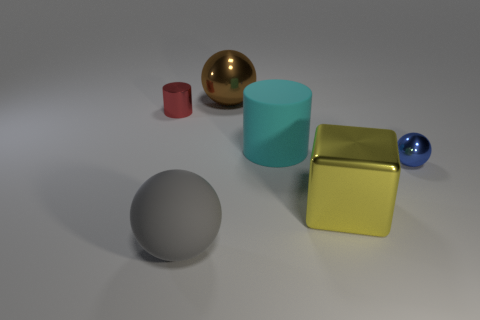What is the shape of the big cyan object?
Your answer should be compact. Cylinder. What is the size of the metal sphere that is behind the red metallic cylinder that is in front of the large metal thing behind the tiny red metal cylinder?
Keep it short and to the point. Large. What number of other objects are the same shape as the gray rubber thing?
Offer a terse response. 2. There is a small object that is on the right side of the rubber ball; does it have the same shape as the big shiny object behind the red shiny object?
Give a very brief answer. Yes. How many balls are either small metal things or yellow metallic objects?
Ensure brevity in your answer.  1. There is a cylinder to the right of the big matte object in front of the metal ball that is in front of the big brown object; what is it made of?
Your answer should be very brief. Rubber. How many other things are the same size as the cyan matte object?
Your answer should be compact. 3. Is the number of gray rubber balls on the left side of the small red cylinder greater than the number of big cyan matte objects?
Make the answer very short. No. There is another metal thing that is the same size as the yellow thing; what is its color?
Your answer should be compact. Brown. There is a cylinder that is in front of the small shiny cylinder; how many big gray rubber balls are behind it?
Give a very brief answer. 0. 